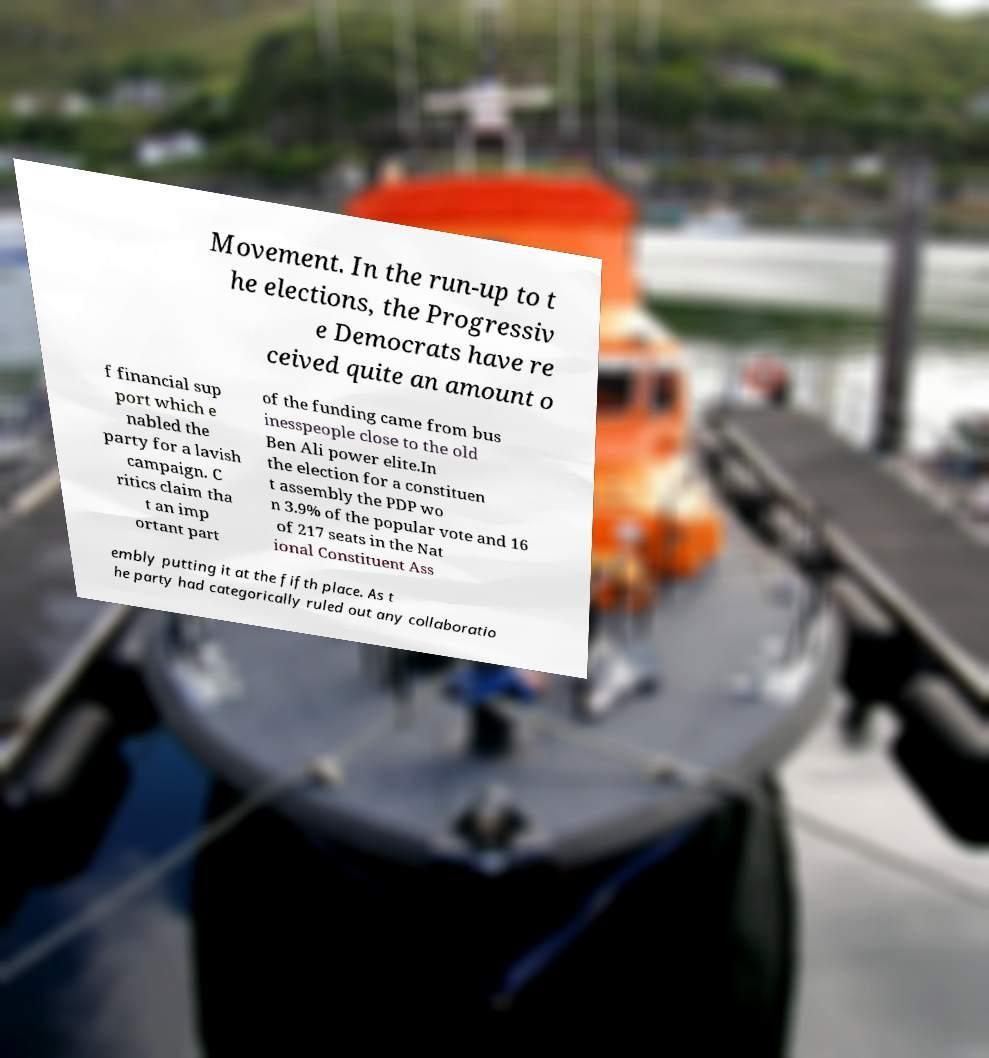Please read and relay the text visible in this image. What does it say? Movement. In the run-up to t he elections, the Progressiv e Democrats have re ceived quite an amount o f financial sup port which e nabled the party for a lavish campaign. C ritics claim tha t an imp ortant part of the funding came from bus inesspeople close to the old Ben Ali power elite.In the election for a constituen t assembly the PDP wo n 3.9% of the popular vote and 16 of 217 seats in the Nat ional Constituent Ass embly putting it at the fifth place. As t he party had categorically ruled out any collaboratio 